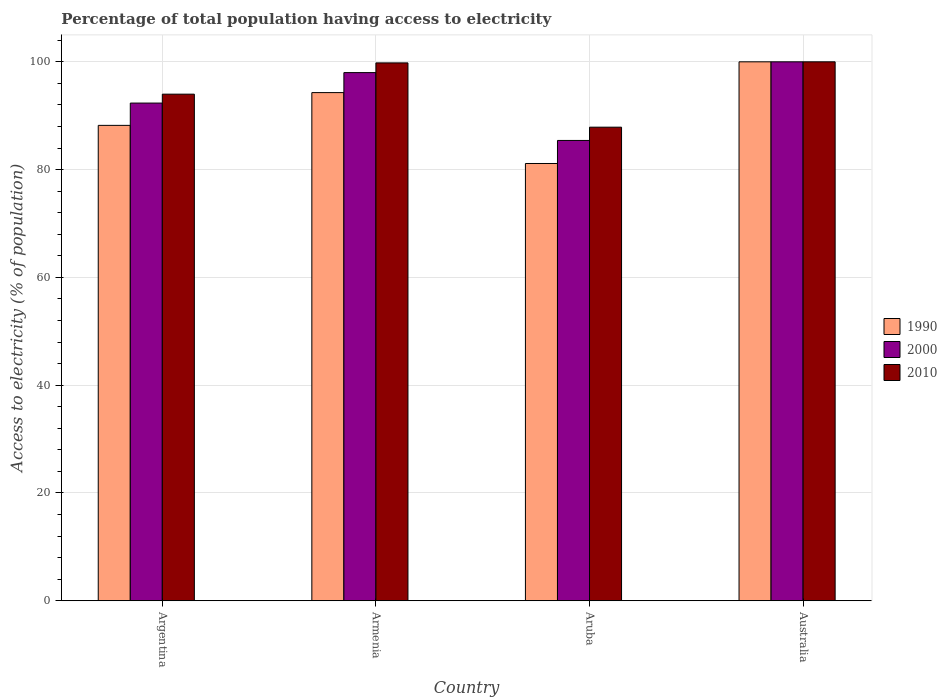How many groups of bars are there?
Make the answer very short. 4. How many bars are there on the 2nd tick from the right?
Offer a very short reply. 3. What is the label of the 3rd group of bars from the left?
Provide a short and direct response. Aruba. In how many cases, is the number of bars for a given country not equal to the number of legend labels?
Provide a short and direct response. 0. What is the percentage of population that have access to electricity in 2010 in Argentina?
Give a very brief answer. 94. Across all countries, what is the maximum percentage of population that have access to electricity in 2000?
Provide a short and direct response. 100. Across all countries, what is the minimum percentage of population that have access to electricity in 1990?
Make the answer very short. 81.14. In which country was the percentage of population that have access to electricity in 2000 minimum?
Keep it short and to the point. Aruba. What is the total percentage of population that have access to electricity in 1990 in the graph?
Provide a short and direct response. 363.63. What is the difference between the percentage of population that have access to electricity in 2010 in Aruba and that in Australia?
Provide a short and direct response. -12.13. What is the difference between the percentage of population that have access to electricity in 2000 in Aruba and the percentage of population that have access to electricity in 2010 in Argentina?
Your answer should be very brief. -8.59. What is the average percentage of population that have access to electricity in 2000 per country?
Provide a succinct answer. 93.94. What is the difference between the percentage of population that have access to electricity of/in 2010 and percentage of population that have access to electricity of/in 2000 in Argentina?
Your answer should be compact. 1.65. In how many countries, is the percentage of population that have access to electricity in 1990 greater than 76 %?
Offer a terse response. 4. What is the ratio of the percentage of population that have access to electricity in 2010 in Argentina to that in Aruba?
Offer a very short reply. 1.07. Is the difference between the percentage of population that have access to electricity in 2010 in Armenia and Aruba greater than the difference between the percentage of population that have access to electricity in 2000 in Armenia and Aruba?
Provide a short and direct response. No. What is the difference between the highest and the second highest percentage of population that have access to electricity in 1990?
Ensure brevity in your answer.  -11.79. What is the difference between the highest and the lowest percentage of population that have access to electricity in 1990?
Provide a short and direct response. 18.86. In how many countries, is the percentage of population that have access to electricity in 2000 greater than the average percentage of population that have access to electricity in 2000 taken over all countries?
Offer a terse response. 2. What does the 1st bar from the right in Australia represents?
Give a very brief answer. 2010. Is it the case that in every country, the sum of the percentage of population that have access to electricity in 1990 and percentage of population that have access to electricity in 2000 is greater than the percentage of population that have access to electricity in 2010?
Your answer should be compact. Yes. How many countries are there in the graph?
Your answer should be very brief. 4. What is the difference between two consecutive major ticks on the Y-axis?
Provide a short and direct response. 20. Are the values on the major ticks of Y-axis written in scientific E-notation?
Your answer should be compact. No. How are the legend labels stacked?
Provide a succinct answer. Vertical. What is the title of the graph?
Give a very brief answer. Percentage of total population having access to electricity. What is the label or title of the Y-axis?
Your answer should be very brief. Access to electricity (% of population). What is the Access to electricity (% of population) in 1990 in Argentina?
Your answer should be compact. 88.21. What is the Access to electricity (% of population) of 2000 in Argentina?
Keep it short and to the point. 92.35. What is the Access to electricity (% of population) in 2010 in Argentina?
Your answer should be very brief. 94. What is the Access to electricity (% of population) of 1990 in Armenia?
Your answer should be very brief. 94.29. What is the Access to electricity (% of population) in 2000 in Armenia?
Give a very brief answer. 98. What is the Access to electricity (% of population) in 2010 in Armenia?
Keep it short and to the point. 99.8. What is the Access to electricity (% of population) in 1990 in Aruba?
Offer a very short reply. 81.14. What is the Access to electricity (% of population) of 2000 in Aruba?
Provide a succinct answer. 85.41. What is the Access to electricity (% of population) in 2010 in Aruba?
Provide a succinct answer. 87.87. What is the Access to electricity (% of population) of 1990 in Australia?
Ensure brevity in your answer.  100. What is the Access to electricity (% of population) of 2010 in Australia?
Make the answer very short. 100. Across all countries, what is the maximum Access to electricity (% of population) in 2000?
Offer a very short reply. 100. Across all countries, what is the minimum Access to electricity (% of population) of 1990?
Offer a terse response. 81.14. Across all countries, what is the minimum Access to electricity (% of population) in 2000?
Offer a very short reply. 85.41. Across all countries, what is the minimum Access to electricity (% of population) of 2010?
Keep it short and to the point. 87.87. What is the total Access to electricity (% of population) of 1990 in the graph?
Provide a succinct answer. 363.63. What is the total Access to electricity (% of population) of 2000 in the graph?
Make the answer very short. 375.76. What is the total Access to electricity (% of population) in 2010 in the graph?
Your answer should be very brief. 381.67. What is the difference between the Access to electricity (% of population) of 1990 in Argentina and that in Armenia?
Your response must be concise. -6.08. What is the difference between the Access to electricity (% of population) of 2000 in Argentina and that in Armenia?
Keep it short and to the point. -5.65. What is the difference between the Access to electricity (% of population) in 1990 in Argentina and that in Aruba?
Offer a terse response. 7.07. What is the difference between the Access to electricity (% of population) of 2000 in Argentina and that in Aruba?
Your answer should be very brief. 6.94. What is the difference between the Access to electricity (% of population) in 2010 in Argentina and that in Aruba?
Your answer should be very brief. 6.13. What is the difference between the Access to electricity (% of population) in 1990 in Argentina and that in Australia?
Make the answer very short. -11.79. What is the difference between the Access to electricity (% of population) of 2000 in Argentina and that in Australia?
Your answer should be very brief. -7.65. What is the difference between the Access to electricity (% of population) in 2010 in Argentina and that in Australia?
Offer a very short reply. -6. What is the difference between the Access to electricity (% of population) in 1990 in Armenia and that in Aruba?
Ensure brevity in your answer.  13.15. What is the difference between the Access to electricity (% of population) in 2000 in Armenia and that in Aruba?
Make the answer very short. 12.59. What is the difference between the Access to electricity (% of population) in 2010 in Armenia and that in Aruba?
Offer a terse response. 11.93. What is the difference between the Access to electricity (% of population) of 1990 in Armenia and that in Australia?
Keep it short and to the point. -5.71. What is the difference between the Access to electricity (% of population) in 2000 in Armenia and that in Australia?
Your response must be concise. -2. What is the difference between the Access to electricity (% of population) in 1990 in Aruba and that in Australia?
Your answer should be very brief. -18.86. What is the difference between the Access to electricity (% of population) of 2000 in Aruba and that in Australia?
Make the answer very short. -14.59. What is the difference between the Access to electricity (% of population) in 2010 in Aruba and that in Australia?
Keep it short and to the point. -12.13. What is the difference between the Access to electricity (% of population) in 1990 in Argentina and the Access to electricity (% of population) in 2000 in Armenia?
Make the answer very short. -9.79. What is the difference between the Access to electricity (% of population) in 1990 in Argentina and the Access to electricity (% of population) in 2010 in Armenia?
Your answer should be very brief. -11.59. What is the difference between the Access to electricity (% of population) in 2000 in Argentina and the Access to electricity (% of population) in 2010 in Armenia?
Offer a terse response. -7.45. What is the difference between the Access to electricity (% of population) of 1990 in Argentina and the Access to electricity (% of population) of 2000 in Aruba?
Your answer should be compact. 2.8. What is the difference between the Access to electricity (% of population) in 1990 in Argentina and the Access to electricity (% of population) in 2010 in Aruba?
Offer a very short reply. 0.33. What is the difference between the Access to electricity (% of population) in 2000 in Argentina and the Access to electricity (% of population) in 2010 in Aruba?
Offer a terse response. 4.47. What is the difference between the Access to electricity (% of population) of 1990 in Argentina and the Access to electricity (% of population) of 2000 in Australia?
Offer a very short reply. -11.79. What is the difference between the Access to electricity (% of population) of 1990 in Argentina and the Access to electricity (% of population) of 2010 in Australia?
Your response must be concise. -11.79. What is the difference between the Access to electricity (% of population) of 2000 in Argentina and the Access to electricity (% of population) of 2010 in Australia?
Offer a very short reply. -7.65. What is the difference between the Access to electricity (% of population) of 1990 in Armenia and the Access to electricity (% of population) of 2000 in Aruba?
Give a very brief answer. 8.88. What is the difference between the Access to electricity (% of population) of 1990 in Armenia and the Access to electricity (% of population) of 2010 in Aruba?
Provide a short and direct response. 6.41. What is the difference between the Access to electricity (% of population) in 2000 in Armenia and the Access to electricity (% of population) in 2010 in Aruba?
Your answer should be very brief. 10.13. What is the difference between the Access to electricity (% of population) of 1990 in Armenia and the Access to electricity (% of population) of 2000 in Australia?
Offer a very short reply. -5.71. What is the difference between the Access to electricity (% of population) of 1990 in Armenia and the Access to electricity (% of population) of 2010 in Australia?
Your answer should be compact. -5.71. What is the difference between the Access to electricity (% of population) in 1990 in Aruba and the Access to electricity (% of population) in 2000 in Australia?
Your response must be concise. -18.86. What is the difference between the Access to electricity (% of population) of 1990 in Aruba and the Access to electricity (% of population) of 2010 in Australia?
Offer a very short reply. -18.86. What is the difference between the Access to electricity (% of population) in 2000 in Aruba and the Access to electricity (% of population) in 2010 in Australia?
Ensure brevity in your answer.  -14.59. What is the average Access to electricity (% of population) of 1990 per country?
Your answer should be very brief. 90.91. What is the average Access to electricity (% of population) of 2000 per country?
Your answer should be very brief. 93.94. What is the average Access to electricity (% of population) of 2010 per country?
Make the answer very short. 95.42. What is the difference between the Access to electricity (% of population) in 1990 and Access to electricity (% of population) in 2000 in Argentina?
Offer a very short reply. -4.14. What is the difference between the Access to electricity (% of population) in 1990 and Access to electricity (% of population) in 2010 in Argentina?
Ensure brevity in your answer.  -5.79. What is the difference between the Access to electricity (% of population) in 2000 and Access to electricity (% of population) in 2010 in Argentina?
Provide a succinct answer. -1.65. What is the difference between the Access to electricity (% of population) in 1990 and Access to electricity (% of population) in 2000 in Armenia?
Provide a succinct answer. -3.71. What is the difference between the Access to electricity (% of population) of 1990 and Access to electricity (% of population) of 2010 in Armenia?
Ensure brevity in your answer.  -5.51. What is the difference between the Access to electricity (% of population) in 1990 and Access to electricity (% of population) in 2000 in Aruba?
Keep it short and to the point. -4.28. What is the difference between the Access to electricity (% of population) in 1990 and Access to electricity (% of population) in 2010 in Aruba?
Give a very brief answer. -6.74. What is the difference between the Access to electricity (% of population) of 2000 and Access to electricity (% of population) of 2010 in Aruba?
Give a very brief answer. -2.46. What is the difference between the Access to electricity (% of population) in 1990 and Access to electricity (% of population) in 2000 in Australia?
Offer a terse response. 0. What is the difference between the Access to electricity (% of population) of 2000 and Access to electricity (% of population) of 2010 in Australia?
Your answer should be compact. 0. What is the ratio of the Access to electricity (% of population) of 1990 in Argentina to that in Armenia?
Your response must be concise. 0.94. What is the ratio of the Access to electricity (% of population) in 2000 in Argentina to that in Armenia?
Make the answer very short. 0.94. What is the ratio of the Access to electricity (% of population) in 2010 in Argentina to that in Armenia?
Provide a short and direct response. 0.94. What is the ratio of the Access to electricity (% of population) of 1990 in Argentina to that in Aruba?
Make the answer very short. 1.09. What is the ratio of the Access to electricity (% of population) in 2000 in Argentina to that in Aruba?
Ensure brevity in your answer.  1.08. What is the ratio of the Access to electricity (% of population) in 2010 in Argentina to that in Aruba?
Ensure brevity in your answer.  1.07. What is the ratio of the Access to electricity (% of population) of 1990 in Argentina to that in Australia?
Your response must be concise. 0.88. What is the ratio of the Access to electricity (% of population) in 2000 in Argentina to that in Australia?
Ensure brevity in your answer.  0.92. What is the ratio of the Access to electricity (% of population) of 1990 in Armenia to that in Aruba?
Give a very brief answer. 1.16. What is the ratio of the Access to electricity (% of population) in 2000 in Armenia to that in Aruba?
Make the answer very short. 1.15. What is the ratio of the Access to electricity (% of population) of 2010 in Armenia to that in Aruba?
Provide a short and direct response. 1.14. What is the ratio of the Access to electricity (% of population) in 1990 in Armenia to that in Australia?
Your response must be concise. 0.94. What is the ratio of the Access to electricity (% of population) of 1990 in Aruba to that in Australia?
Ensure brevity in your answer.  0.81. What is the ratio of the Access to electricity (% of population) of 2000 in Aruba to that in Australia?
Your response must be concise. 0.85. What is the ratio of the Access to electricity (% of population) of 2010 in Aruba to that in Australia?
Offer a terse response. 0.88. What is the difference between the highest and the second highest Access to electricity (% of population) in 1990?
Your response must be concise. 5.71. What is the difference between the highest and the lowest Access to electricity (% of population) in 1990?
Your response must be concise. 18.86. What is the difference between the highest and the lowest Access to electricity (% of population) of 2000?
Make the answer very short. 14.59. What is the difference between the highest and the lowest Access to electricity (% of population) in 2010?
Your answer should be very brief. 12.13. 